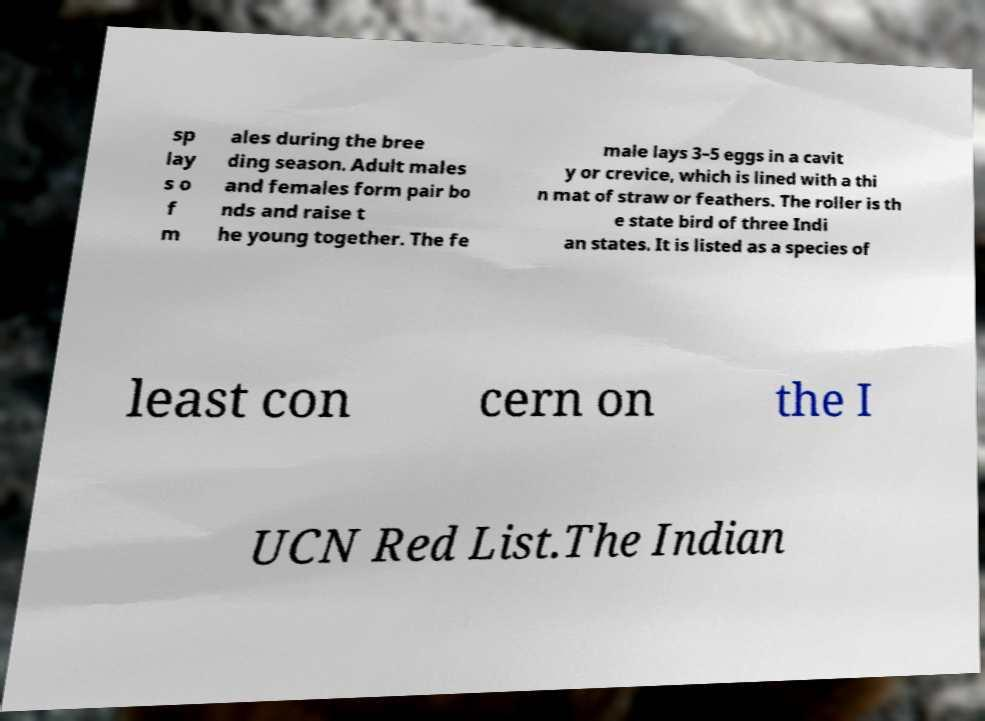Please read and relay the text visible in this image. What does it say? sp lay s o f m ales during the bree ding season. Adult males and females form pair bo nds and raise t he young together. The fe male lays 3–5 eggs in a cavit y or crevice, which is lined with a thi n mat of straw or feathers. The roller is th e state bird of three Indi an states. It is listed as a species of least con cern on the I UCN Red List.The Indian 